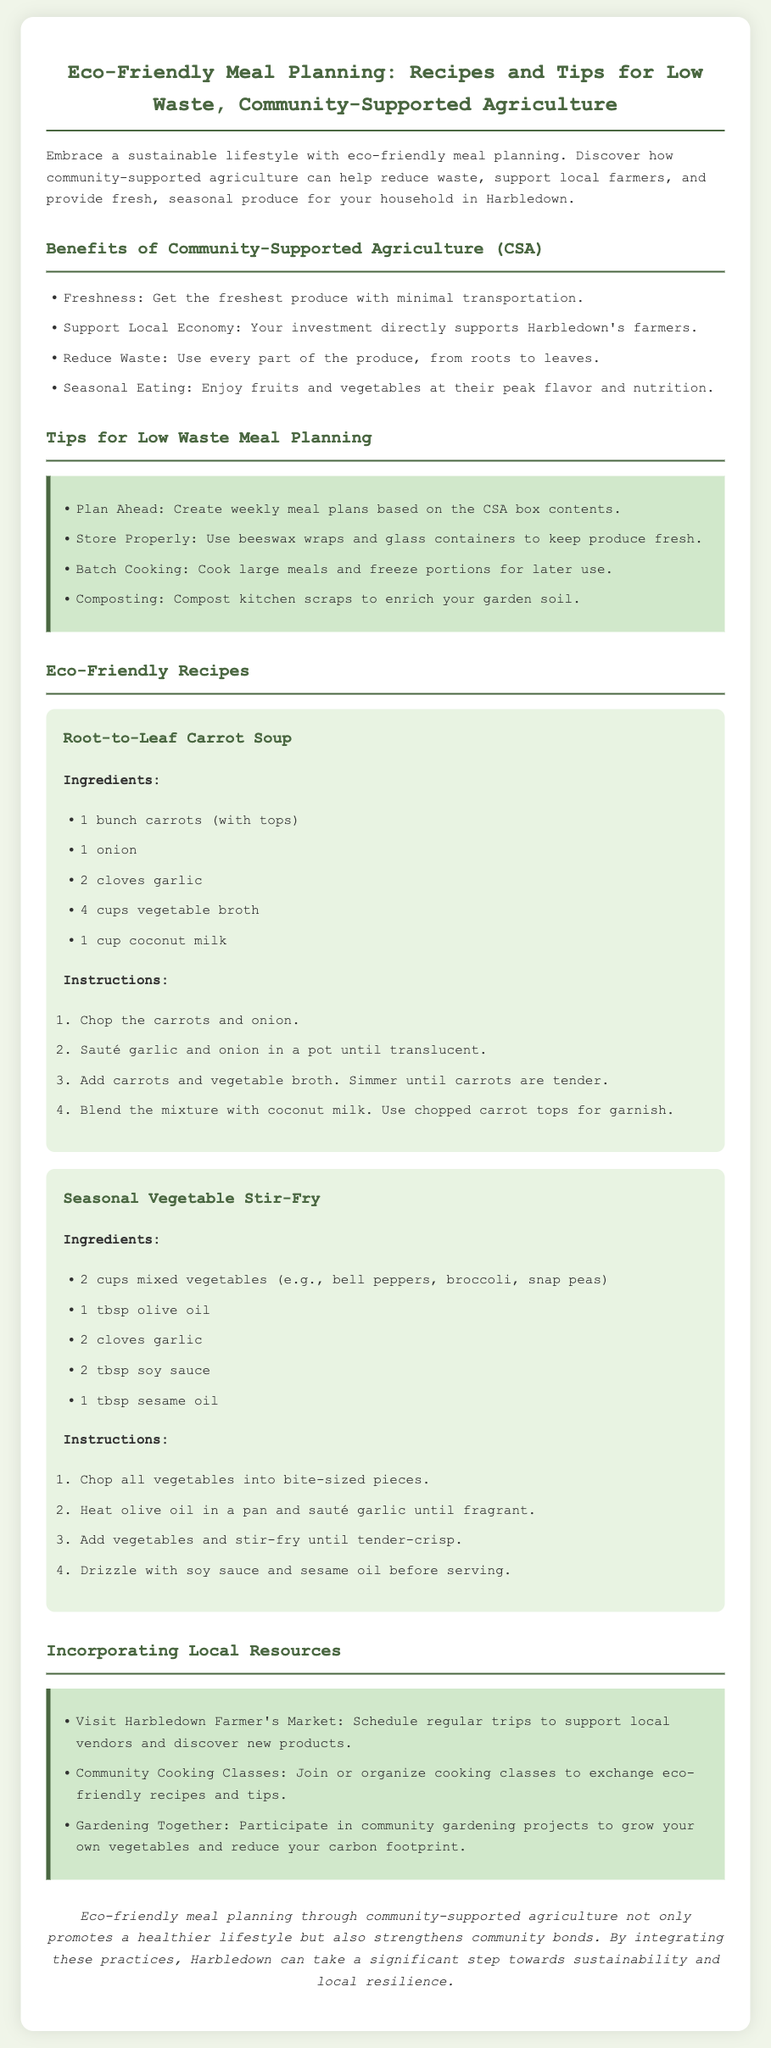What is the title of the document? The title of the document is given in the header section.
Answer: Eco-Friendly Meal Planning: Recipes and Tips for Low Waste, Community-Supported Agriculture What is one benefit of Community-Supported Agriculture? A benefit of Community-Supported Agriculture is listed in the section about its benefits.
Answer: Freshness What is one tip for low waste meal planning? A tip for low waste meal planning is provided in the tips section.
Answer: Plan Ahead How many cloves of garlic are used in the Seasonal Vegetable Stir-Fry recipe? The number of garlic cloves is specified in the ingredients list of the recipe.
Answer: 2 cloves What is the main vegetable used in the Root-to-Leaf Carrot Soup? The main vegetable of the soup is identified in the ingredients list.
Answer: Carrots Which oil is used in the Seasonal Vegetable Stir-Fry recipe? The type of oil used is specified in the ingredients list of the recipe.
Answer: Olive oil How many cups of mixed vegetables are in the Seasonal Vegetable Stir-Fry? The amount of mixed vegetables is mentioned in the ingredients list.
Answer: 2 cups What is a suggested local resource to visit in Harbledown? The document provides a local resource that can be visited.
Answer: Harbledown Farmer's Market What does the conclusion suggest for Harbledown? The conclusion contains the suggestion for the community based on the practices mentioned.
Answer: Sustainability and local resilience 